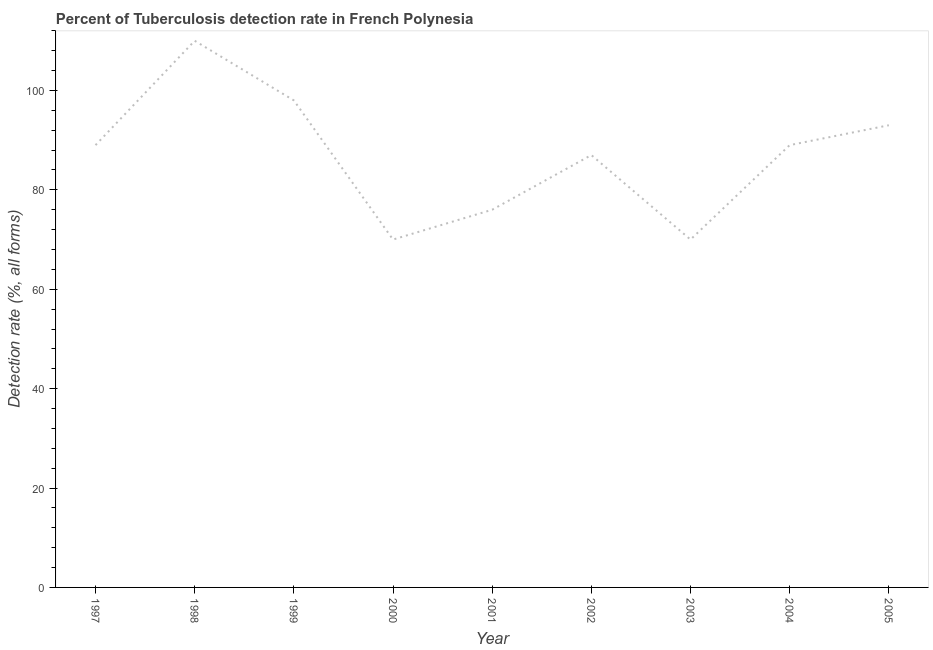What is the detection rate of tuberculosis in 2000?
Keep it short and to the point. 70. Across all years, what is the maximum detection rate of tuberculosis?
Offer a terse response. 110. Across all years, what is the minimum detection rate of tuberculosis?
Keep it short and to the point. 70. What is the sum of the detection rate of tuberculosis?
Your answer should be compact. 782. What is the difference between the detection rate of tuberculosis in 1997 and 2002?
Your answer should be compact. 2. What is the average detection rate of tuberculosis per year?
Give a very brief answer. 86.89. What is the median detection rate of tuberculosis?
Your response must be concise. 89. Do a majority of the years between 2003 and 2005 (inclusive) have detection rate of tuberculosis greater than 52 %?
Your answer should be compact. Yes. What is the ratio of the detection rate of tuberculosis in 1997 to that in 1998?
Keep it short and to the point. 0.81. Is the sum of the detection rate of tuberculosis in 1998 and 1999 greater than the maximum detection rate of tuberculosis across all years?
Offer a terse response. Yes. What is the difference between the highest and the lowest detection rate of tuberculosis?
Your answer should be compact. 40. Are the values on the major ticks of Y-axis written in scientific E-notation?
Your answer should be compact. No. Does the graph contain any zero values?
Your response must be concise. No. What is the title of the graph?
Your response must be concise. Percent of Tuberculosis detection rate in French Polynesia. What is the label or title of the X-axis?
Ensure brevity in your answer.  Year. What is the label or title of the Y-axis?
Provide a succinct answer. Detection rate (%, all forms). What is the Detection rate (%, all forms) of 1997?
Offer a very short reply. 89. What is the Detection rate (%, all forms) in 1998?
Keep it short and to the point. 110. What is the Detection rate (%, all forms) in 1999?
Provide a short and direct response. 98. What is the Detection rate (%, all forms) of 2000?
Ensure brevity in your answer.  70. What is the Detection rate (%, all forms) of 2001?
Give a very brief answer. 76. What is the Detection rate (%, all forms) of 2002?
Keep it short and to the point. 87. What is the Detection rate (%, all forms) in 2004?
Ensure brevity in your answer.  89. What is the Detection rate (%, all forms) in 2005?
Keep it short and to the point. 93. What is the difference between the Detection rate (%, all forms) in 1997 and 1998?
Offer a very short reply. -21. What is the difference between the Detection rate (%, all forms) in 1997 and 2000?
Offer a very short reply. 19. What is the difference between the Detection rate (%, all forms) in 1997 and 2001?
Keep it short and to the point. 13. What is the difference between the Detection rate (%, all forms) in 1997 and 2002?
Provide a succinct answer. 2. What is the difference between the Detection rate (%, all forms) in 1998 and 1999?
Offer a terse response. 12. What is the difference between the Detection rate (%, all forms) in 1998 and 2000?
Give a very brief answer. 40. What is the difference between the Detection rate (%, all forms) in 1998 and 2001?
Offer a very short reply. 34. What is the difference between the Detection rate (%, all forms) in 1998 and 2003?
Offer a very short reply. 40. What is the difference between the Detection rate (%, all forms) in 1998 and 2004?
Provide a succinct answer. 21. What is the difference between the Detection rate (%, all forms) in 1999 and 2000?
Provide a succinct answer. 28. What is the difference between the Detection rate (%, all forms) in 1999 and 2002?
Provide a short and direct response. 11. What is the difference between the Detection rate (%, all forms) in 1999 and 2003?
Provide a short and direct response. 28. What is the difference between the Detection rate (%, all forms) in 1999 and 2004?
Your response must be concise. 9. What is the difference between the Detection rate (%, all forms) in 1999 and 2005?
Keep it short and to the point. 5. What is the difference between the Detection rate (%, all forms) in 2000 and 2002?
Your answer should be very brief. -17. What is the difference between the Detection rate (%, all forms) in 2000 and 2004?
Ensure brevity in your answer.  -19. What is the difference between the Detection rate (%, all forms) in 2000 and 2005?
Give a very brief answer. -23. What is the difference between the Detection rate (%, all forms) in 2001 and 2002?
Provide a succinct answer. -11. What is the difference between the Detection rate (%, all forms) in 2001 and 2004?
Provide a succinct answer. -13. What is the difference between the Detection rate (%, all forms) in 2002 and 2003?
Keep it short and to the point. 17. What is the difference between the Detection rate (%, all forms) in 2002 and 2004?
Offer a terse response. -2. What is the ratio of the Detection rate (%, all forms) in 1997 to that in 1998?
Your response must be concise. 0.81. What is the ratio of the Detection rate (%, all forms) in 1997 to that in 1999?
Provide a succinct answer. 0.91. What is the ratio of the Detection rate (%, all forms) in 1997 to that in 2000?
Provide a succinct answer. 1.27. What is the ratio of the Detection rate (%, all forms) in 1997 to that in 2001?
Make the answer very short. 1.17. What is the ratio of the Detection rate (%, all forms) in 1997 to that in 2002?
Your answer should be compact. 1.02. What is the ratio of the Detection rate (%, all forms) in 1997 to that in 2003?
Keep it short and to the point. 1.27. What is the ratio of the Detection rate (%, all forms) in 1997 to that in 2004?
Give a very brief answer. 1. What is the ratio of the Detection rate (%, all forms) in 1998 to that in 1999?
Ensure brevity in your answer.  1.12. What is the ratio of the Detection rate (%, all forms) in 1998 to that in 2000?
Offer a terse response. 1.57. What is the ratio of the Detection rate (%, all forms) in 1998 to that in 2001?
Your response must be concise. 1.45. What is the ratio of the Detection rate (%, all forms) in 1998 to that in 2002?
Provide a succinct answer. 1.26. What is the ratio of the Detection rate (%, all forms) in 1998 to that in 2003?
Your answer should be compact. 1.57. What is the ratio of the Detection rate (%, all forms) in 1998 to that in 2004?
Ensure brevity in your answer.  1.24. What is the ratio of the Detection rate (%, all forms) in 1998 to that in 2005?
Provide a succinct answer. 1.18. What is the ratio of the Detection rate (%, all forms) in 1999 to that in 2000?
Ensure brevity in your answer.  1.4. What is the ratio of the Detection rate (%, all forms) in 1999 to that in 2001?
Offer a very short reply. 1.29. What is the ratio of the Detection rate (%, all forms) in 1999 to that in 2002?
Offer a terse response. 1.13. What is the ratio of the Detection rate (%, all forms) in 1999 to that in 2004?
Your answer should be compact. 1.1. What is the ratio of the Detection rate (%, all forms) in 1999 to that in 2005?
Offer a very short reply. 1.05. What is the ratio of the Detection rate (%, all forms) in 2000 to that in 2001?
Provide a succinct answer. 0.92. What is the ratio of the Detection rate (%, all forms) in 2000 to that in 2002?
Provide a succinct answer. 0.81. What is the ratio of the Detection rate (%, all forms) in 2000 to that in 2003?
Provide a succinct answer. 1. What is the ratio of the Detection rate (%, all forms) in 2000 to that in 2004?
Offer a terse response. 0.79. What is the ratio of the Detection rate (%, all forms) in 2000 to that in 2005?
Your answer should be compact. 0.75. What is the ratio of the Detection rate (%, all forms) in 2001 to that in 2002?
Provide a succinct answer. 0.87. What is the ratio of the Detection rate (%, all forms) in 2001 to that in 2003?
Provide a short and direct response. 1.09. What is the ratio of the Detection rate (%, all forms) in 2001 to that in 2004?
Offer a terse response. 0.85. What is the ratio of the Detection rate (%, all forms) in 2001 to that in 2005?
Your response must be concise. 0.82. What is the ratio of the Detection rate (%, all forms) in 2002 to that in 2003?
Offer a very short reply. 1.24. What is the ratio of the Detection rate (%, all forms) in 2002 to that in 2004?
Offer a very short reply. 0.98. What is the ratio of the Detection rate (%, all forms) in 2002 to that in 2005?
Your response must be concise. 0.94. What is the ratio of the Detection rate (%, all forms) in 2003 to that in 2004?
Your response must be concise. 0.79. What is the ratio of the Detection rate (%, all forms) in 2003 to that in 2005?
Make the answer very short. 0.75. 